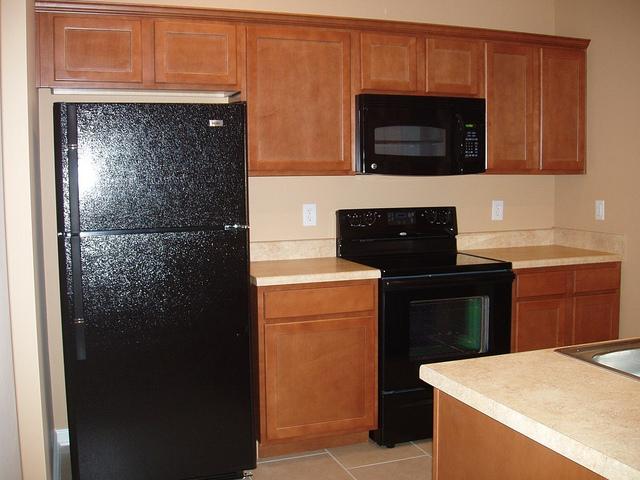Where is the microwave oven?
Give a very brief answer. Above stove. Is the kitchen new?
Give a very brief answer. Yes. What color are the appliances?
Give a very brief answer. Black. 